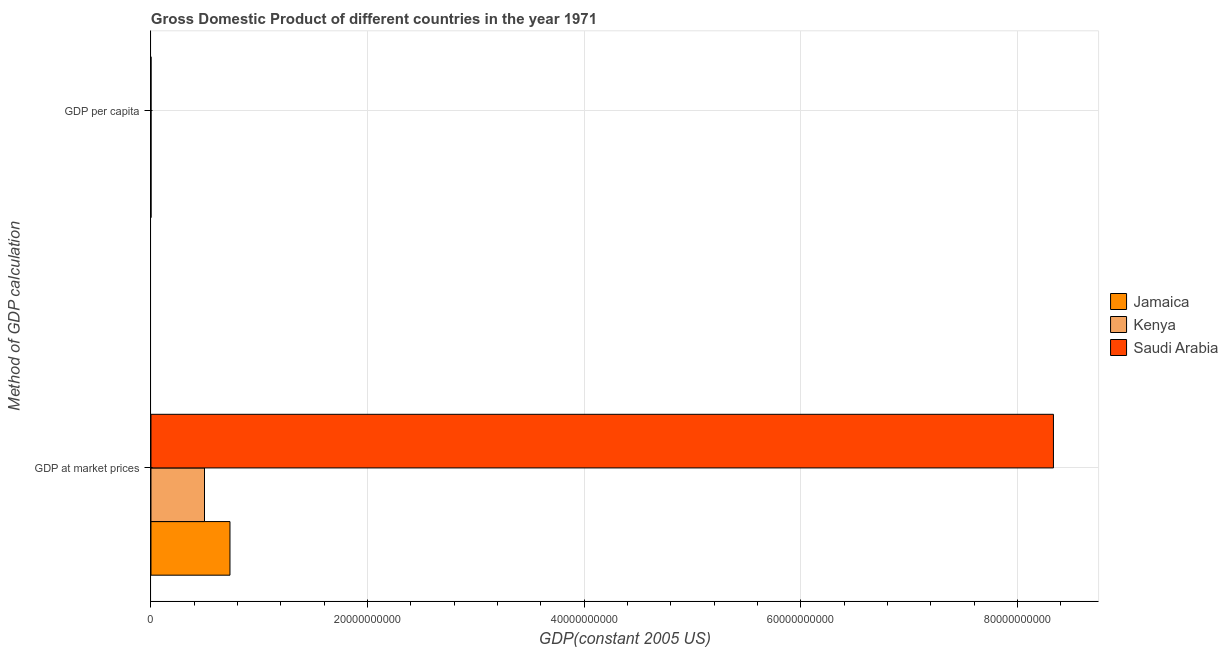How many different coloured bars are there?
Give a very brief answer. 3. How many groups of bars are there?
Provide a succinct answer. 2. Are the number of bars per tick equal to the number of legend labels?
Provide a succinct answer. Yes. How many bars are there on the 2nd tick from the bottom?
Your answer should be compact. 3. What is the label of the 2nd group of bars from the top?
Your answer should be very brief. GDP at market prices. What is the gdp per capita in Jamaica?
Your response must be concise. 3848.37. Across all countries, what is the maximum gdp per capita?
Provide a short and direct response. 1.37e+04. Across all countries, what is the minimum gdp per capita?
Keep it short and to the point. 424.04. In which country was the gdp at market prices maximum?
Offer a very short reply. Saudi Arabia. In which country was the gdp per capita minimum?
Your response must be concise. Kenya. What is the total gdp per capita in the graph?
Provide a short and direct response. 1.79e+04. What is the difference between the gdp per capita in Saudi Arabia and that in Jamaica?
Make the answer very short. 9821.59. What is the difference between the gdp per capita in Saudi Arabia and the gdp at market prices in Kenya?
Offer a very short reply. -4.94e+09. What is the average gdp at market prices per country?
Offer a terse response. 3.19e+1. What is the difference between the gdp per capita and gdp at market prices in Jamaica?
Your answer should be very brief. -7.30e+09. In how many countries, is the gdp per capita greater than 72000000000 US$?
Offer a very short reply. 0. What is the ratio of the gdp per capita in Saudi Arabia to that in Jamaica?
Ensure brevity in your answer.  3.55. Is the gdp at market prices in Jamaica less than that in Saudi Arabia?
Provide a short and direct response. Yes. What does the 1st bar from the top in GDP per capita represents?
Your answer should be very brief. Saudi Arabia. What does the 1st bar from the bottom in GDP per capita represents?
Give a very brief answer. Jamaica. How many bars are there?
Make the answer very short. 6. What is the difference between two consecutive major ticks on the X-axis?
Provide a short and direct response. 2.00e+1. Are the values on the major ticks of X-axis written in scientific E-notation?
Provide a short and direct response. No. Does the graph contain grids?
Make the answer very short. Yes. How many legend labels are there?
Provide a succinct answer. 3. How are the legend labels stacked?
Provide a short and direct response. Vertical. What is the title of the graph?
Your response must be concise. Gross Domestic Product of different countries in the year 1971. Does "Barbados" appear as one of the legend labels in the graph?
Your answer should be very brief. No. What is the label or title of the X-axis?
Offer a terse response. GDP(constant 2005 US). What is the label or title of the Y-axis?
Your answer should be very brief. Method of GDP calculation. What is the GDP(constant 2005 US) of Jamaica in GDP at market prices?
Offer a very short reply. 7.30e+09. What is the GDP(constant 2005 US) of Kenya in GDP at market prices?
Provide a short and direct response. 4.94e+09. What is the GDP(constant 2005 US) of Saudi Arabia in GDP at market prices?
Give a very brief answer. 8.33e+1. What is the GDP(constant 2005 US) in Jamaica in GDP per capita?
Provide a succinct answer. 3848.37. What is the GDP(constant 2005 US) in Kenya in GDP per capita?
Offer a very short reply. 424.04. What is the GDP(constant 2005 US) in Saudi Arabia in GDP per capita?
Provide a succinct answer. 1.37e+04. Across all Method of GDP calculation, what is the maximum GDP(constant 2005 US) of Jamaica?
Give a very brief answer. 7.30e+09. Across all Method of GDP calculation, what is the maximum GDP(constant 2005 US) in Kenya?
Offer a terse response. 4.94e+09. Across all Method of GDP calculation, what is the maximum GDP(constant 2005 US) of Saudi Arabia?
Ensure brevity in your answer.  8.33e+1. Across all Method of GDP calculation, what is the minimum GDP(constant 2005 US) in Jamaica?
Ensure brevity in your answer.  3848.37. Across all Method of GDP calculation, what is the minimum GDP(constant 2005 US) in Kenya?
Your answer should be very brief. 424.04. Across all Method of GDP calculation, what is the minimum GDP(constant 2005 US) of Saudi Arabia?
Give a very brief answer. 1.37e+04. What is the total GDP(constant 2005 US) of Jamaica in the graph?
Give a very brief answer. 7.30e+09. What is the total GDP(constant 2005 US) in Kenya in the graph?
Make the answer very short. 4.94e+09. What is the total GDP(constant 2005 US) in Saudi Arabia in the graph?
Offer a very short reply. 8.33e+1. What is the difference between the GDP(constant 2005 US) of Jamaica in GDP at market prices and that in GDP per capita?
Give a very brief answer. 7.30e+09. What is the difference between the GDP(constant 2005 US) in Kenya in GDP at market prices and that in GDP per capita?
Your answer should be very brief. 4.94e+09. What is the difference between the GDP(constant 2005 US) of Saudi Arabia in GDP at market prices and that in GDP per capita?
Provide a succinct answer. 8.33e+1. What is the difference between the GDP(constant 2005 US) in Jamaica in GDP at market prices and the GDP(constant 2005 US) in Kenya in GDP per capita?
Keep it short and to the point. 7.30e+09. What is the difference between the GDP(constant 2005 US) of Jamaica in GDP at market prices and the GDP(constant 2005 US) of Saudi Arabia in GDP per capita?
Provide a succinct answer. 7.30e+09. What is the difference between the GDP(constant 2005 US) of Kenya in GDP at market prices and the GDP(constant 2005 US) of Saudi Arabia in GDP per capita?
Your answer should be very brief. 4.94e+09. What is the average GDP(constant 2005 US) in Jamaica per Method of GDP calculation?
Ensure brevity in your answer.  3.65e+09. What is the average GDP(constant 2005 US) in Kenya per Method of GDP calculation?
Provide a succinct answer. 2.47e+09. What is the average GDP(constant 2005 US) of Saudi Arabia per Method of GDP calculation?
Your answer should be compact. 4.17e+1. What is the difference between the GDP(constant 2005 US) in Jamaica and GDP(constant 2005 US) in Kenya in GDP at market prices?
Ensure brevity in your answer.  2.35e+09. What is the difference between the GDP(constant 2005 US) of Jamaica and GDP(constant 2005 US) of Saudi Arabia in GDP at market prices?
Offer a very short reply. -7.60e+1. What is the difference between the GDP(constant 2005 US) of Kenya and GDP(constant 2005 US) of Saudi Arabia in GDP at market prices?
Ensure brevity in your answer.  -7.84e+1. What is the difference between the GDP(constant 2005 US) in Jamaica and GDP(constant 2005 US) in Kenya in GDP per capita?
Your answer should be very brief. 3424.33. What is the difference between the GDP(constant 2005 US) of Jamaica and GDP(constant 2005 US) of Saudi Arabia in GDP per capita?
Ensure brevity in your answer.  -9821.59. What is the difference between the GDP(constant 2005 US) of Kenya and GDP(constant 2005 US) of Saudi Arabia in GDP per capita?
Give a very brief answer. -1.32e+04. What is the ratio of the GDP(constant 2005 US) in Jamaica in GDP at market prices to that in GDP per capita?
Keep it short and to the point. 1.90e+06. What is the ratio of the GDP(constant 2005 US) in Kenya in GDP at market prices to that in GDP per capita?
Provide a succinct answer. 1.17e+07. What is the ratio of the GDP(constant 2005 US) of Saudi Arabia in GDP at market prices to that in GDP per capita?
Your answer should be compact. 6.10e+06. What is the difference between the highest and the second highest GDP(constant 2005 US) of Jamaica?
Your answer should be compact. 7.30e+09. What is the difference between the highest and the second highest GDP(constant 2005 US) of Kenya?
Your response must be concise. 4.94e+09. What is the difference between the highest and the second highest GDP(constant 2005 US) in Saudi Arabia?
Give a very brief answer. 8.33e+1. What is the difference between the highest and the lowest GDP(constant 2005 US) in Jamaica?
Your answer should be very brief. 7.30e+09. What is the difference between the highest and the lowest GDP(constant 2005 US) in Kenya?
Make the answer very short. 4.94e+09. What is the difference between the highest and the lowest GDP(constant 2005 US) in Saudi Arabia?
Make the answer very short. 8.33e+1. 